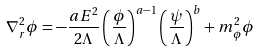<formula> <loc_0><loc_0><loc_500><loc_500>\nabla ^ { 2 } _ { r } \phi = - \frac { a E ^ { 2 } } { 2 \Lambda } \left ( \frac { \phi } { \Lambda } \right ) ^ { a - 1 } \left ( \frac { \psi } { \Lambda } \right ) ^ { b } + m _ { \phi } ^ { 2 } \phi</formula> 